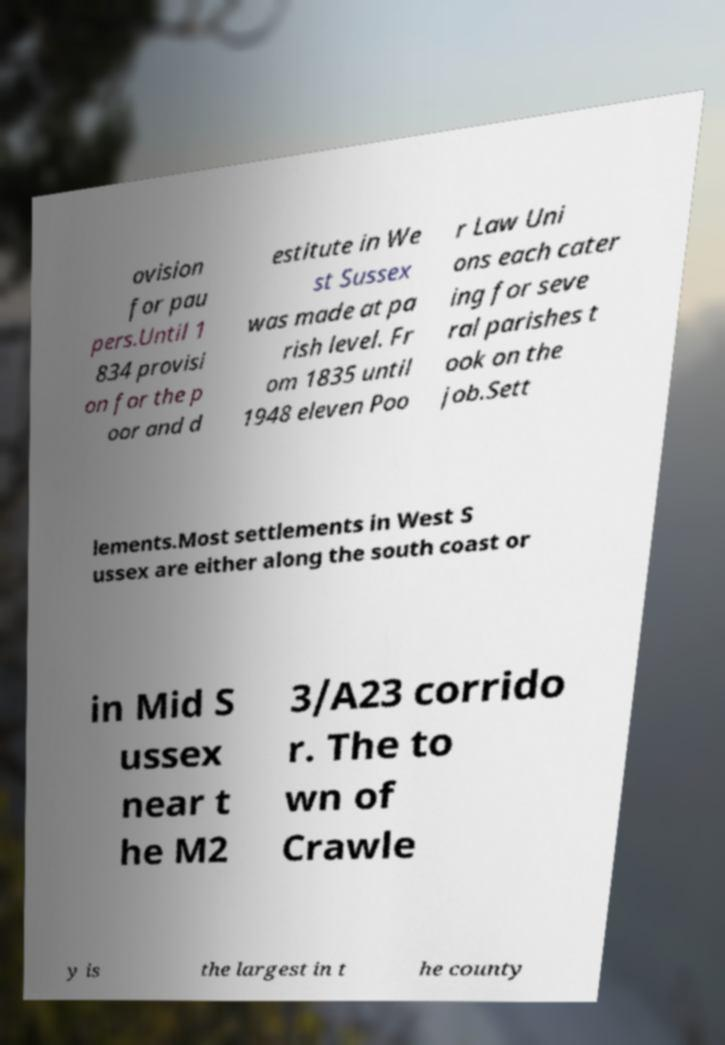I need the written content from this picture converted into text. Can you do that? ovision for pau pers.Until 1 834 provisi on for the p oor and d estitute in We st Sussex was made at pa rish level. Fr om 1835 until 1948 eleven Poo r Law Uni ons each cater ing for seve ral parishes t ook on the job.Sett lements.Most settlements in West S ussex are either along the south coast or in Mid S ussex near t he M2 3/A23 corrido r. The to wn of Crawle y is the largest in t he county 